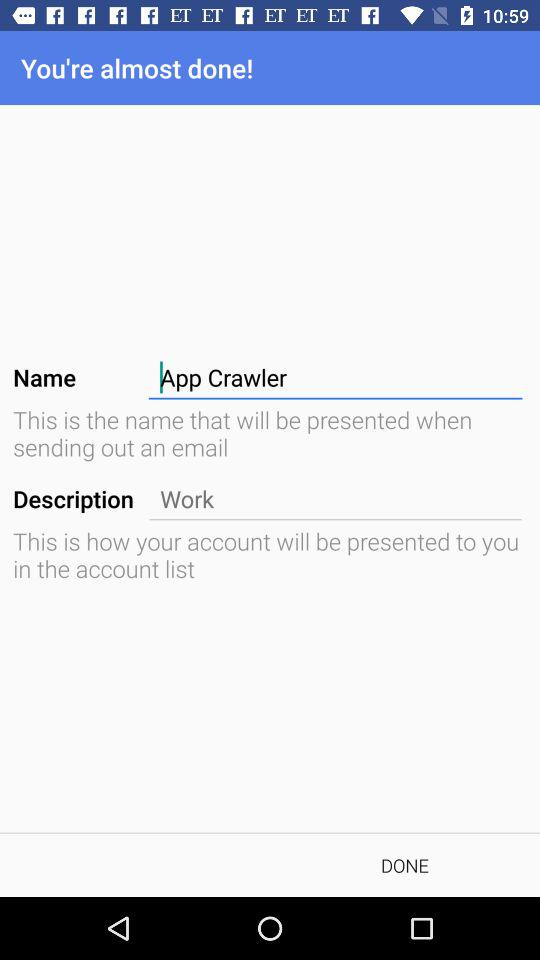What is the user name? The user name is App Crawler. 